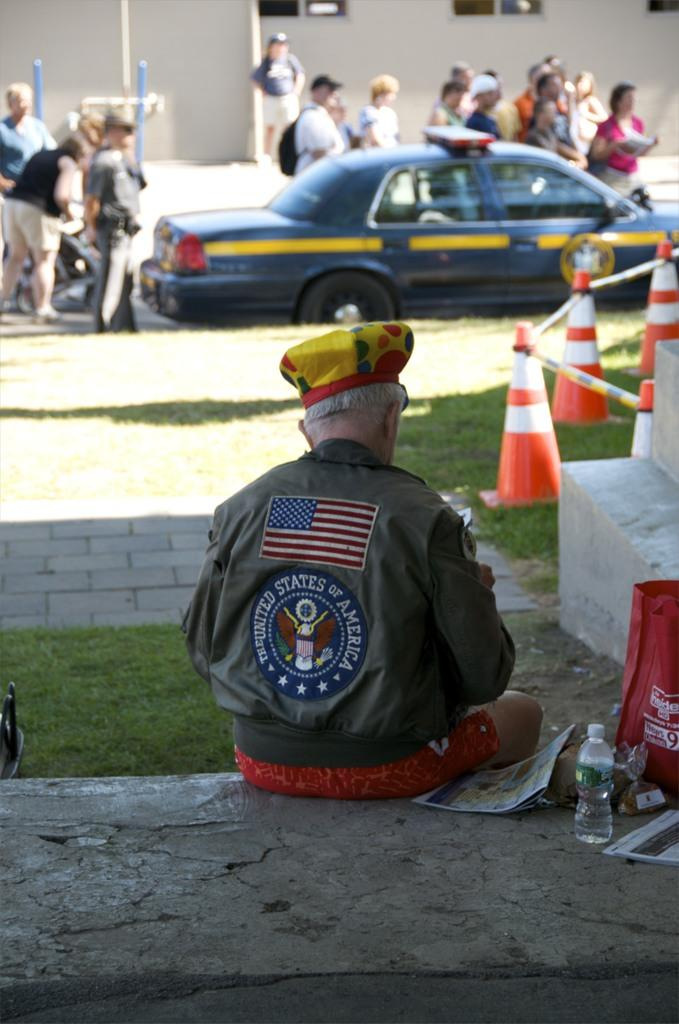What is the person in the image doing? The person is sitting on the ground in the image. What can be seen in the background of the image? There are traffic cones, grass, a car, people, and a building in the background of the image. What type of pancake is being served by the band in the image? There is no band or pancake present in the image. How many oranges are visible on the person's head in the image? There are no oranges or people with oranges on their heads in the image. 